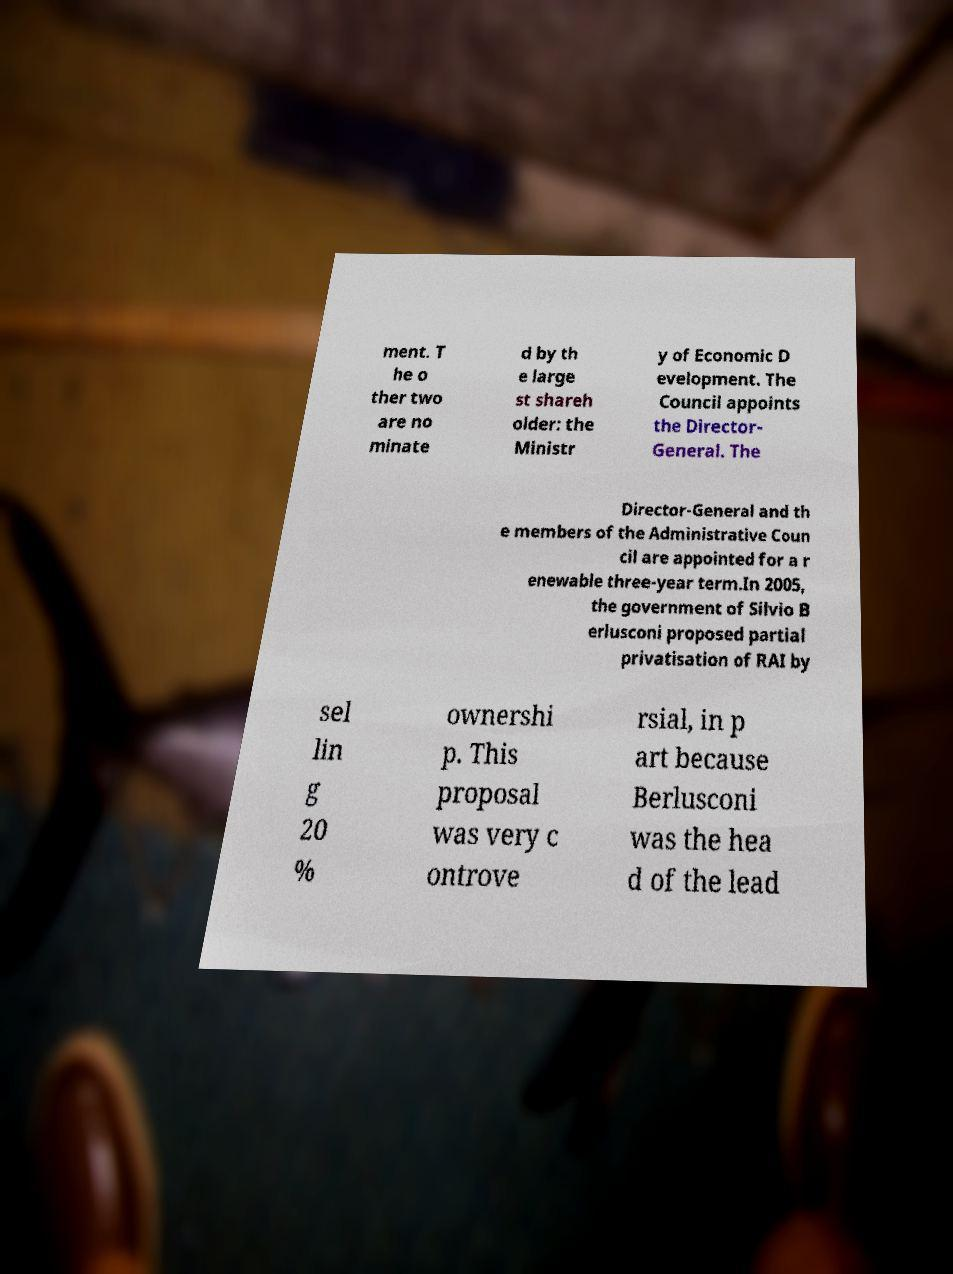Please identify and transcribe the text found in this image. ment. T he o ther two are no minate d by th e large st shareh older: the Ministr y of Economic D evelopment. The Council appoints the Director- General. The Director-General and th e members of the Administrative Coun cil are appointed for a r enewable three-year term.In 2005, the government of Silvio B erlusconi proposed partial privatisation of RAI by sel lin g 20 % ownershi p. This proposal was very c ontrove rsial, in p art because Berlusconi was the hea d of the lead 